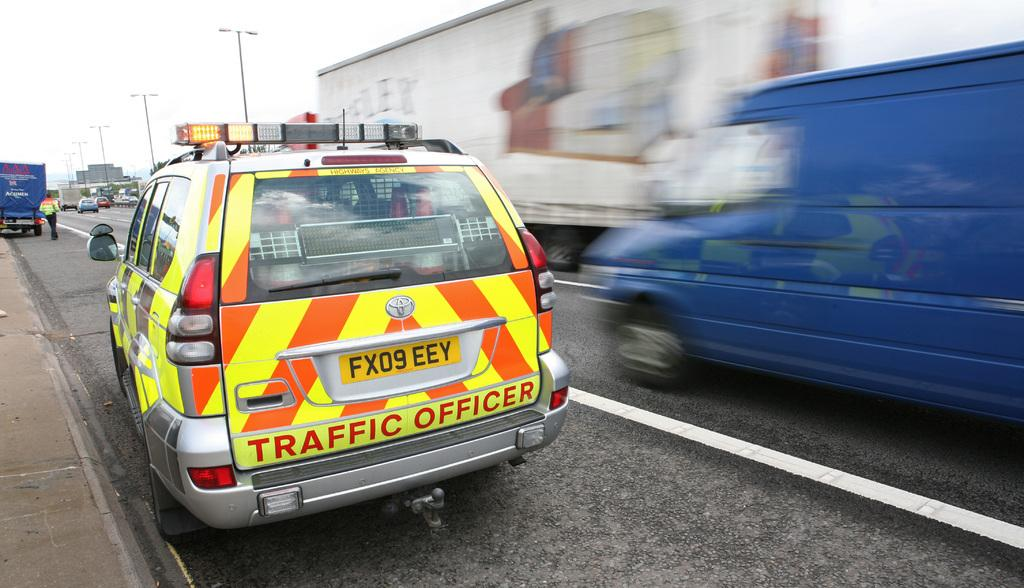Provide a one-sentence caption for the provided image. An orange and yellow striped vehicle with Traffic Officer written on the back. 